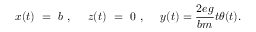<formula> <loc_0><loc_0><loc_500><loc_500>x ( t ) = b , z ( t ) = 0 , y ( t ) = { \frac { 2 e g } { b m } } t \theta ( t ) .</formula> 